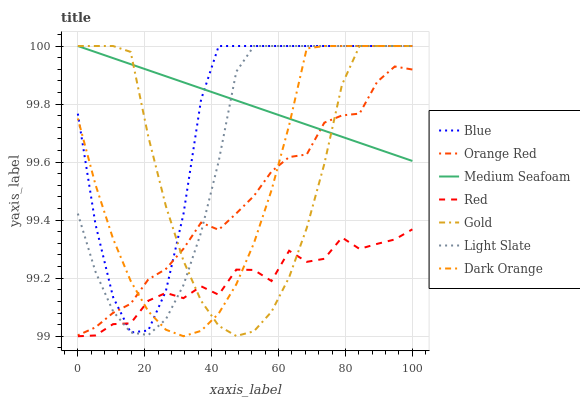Does Red have the minimum area under the curve?
Answer yes or no. Yes. Does Medium Seafoam have the maximum area under the curve?
Answer yes or no. Yes. Does Dark Orange have the minimum area under the curve?
Answer yes or no. No. Does Dark Orange have the maximum area under the curve?
Answer yes or no. No. Is Medium Seafoam the smoothest?
Answer yes or no. Yes. Is Red the roughest?
Answer yes or no. Yes. Is Dark Orange the smoothest?
Answer yes or no. No. Is Dark Orange the roughest?
Answer yes or no. No. Does Red have the lowest value?
Answer yes or no. Yes. Does Dark Orange have the lowest value?
Answer yes or no. No. Does Medium Seafoam have the highest value?
Answer yes or no. Yes. Does Orange Red have the highest value?
Answer yes or no. No. Is Red less than Medium Seafoam?
Answer yes or no. Yes. Is Orange Red greater than Red?
Answer yes or no. Yes. Does Light Slate intersect Gold?
Answer yes or no. Yes. Is Light Slate less than Gold?
Answer yes or no. No. Is Light Slate greater than Gold?
Answer yes or no. No. Does Red intersect Medium Seafoam?
Answer yes or no. No. 